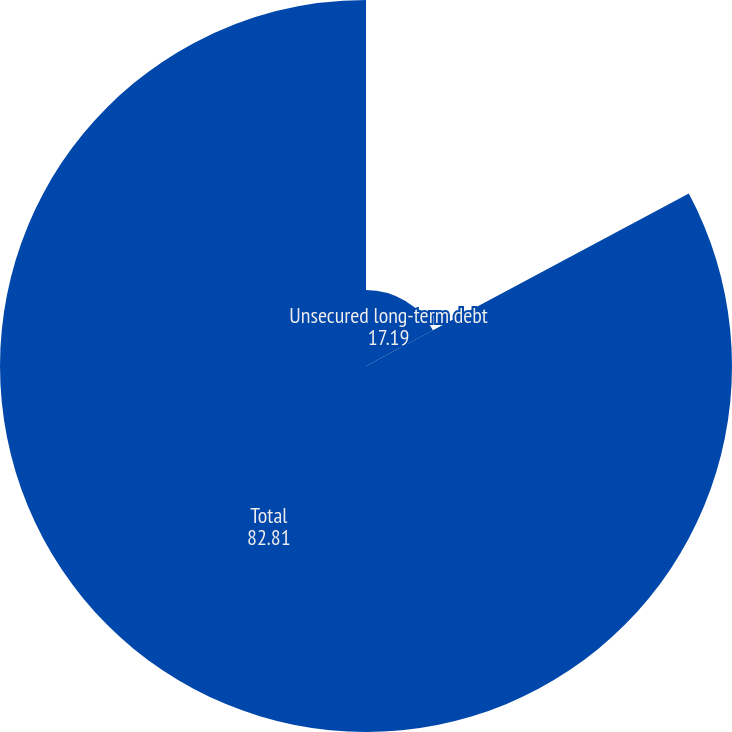Convert chart. <chart><loc_0><loc_0><loc_500><loc_500><pie_chart><fcel>Unsecured long-term debt<fcel>Total<nl><fcel>17.19%<fcel>82.81%<nl></chart> 